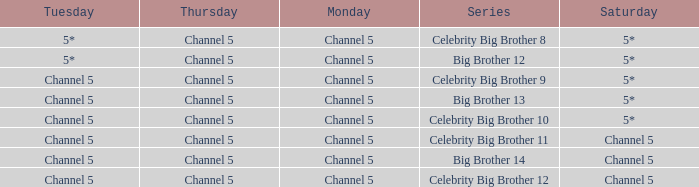Which Tuesday does big brother 12 air? 5*. 